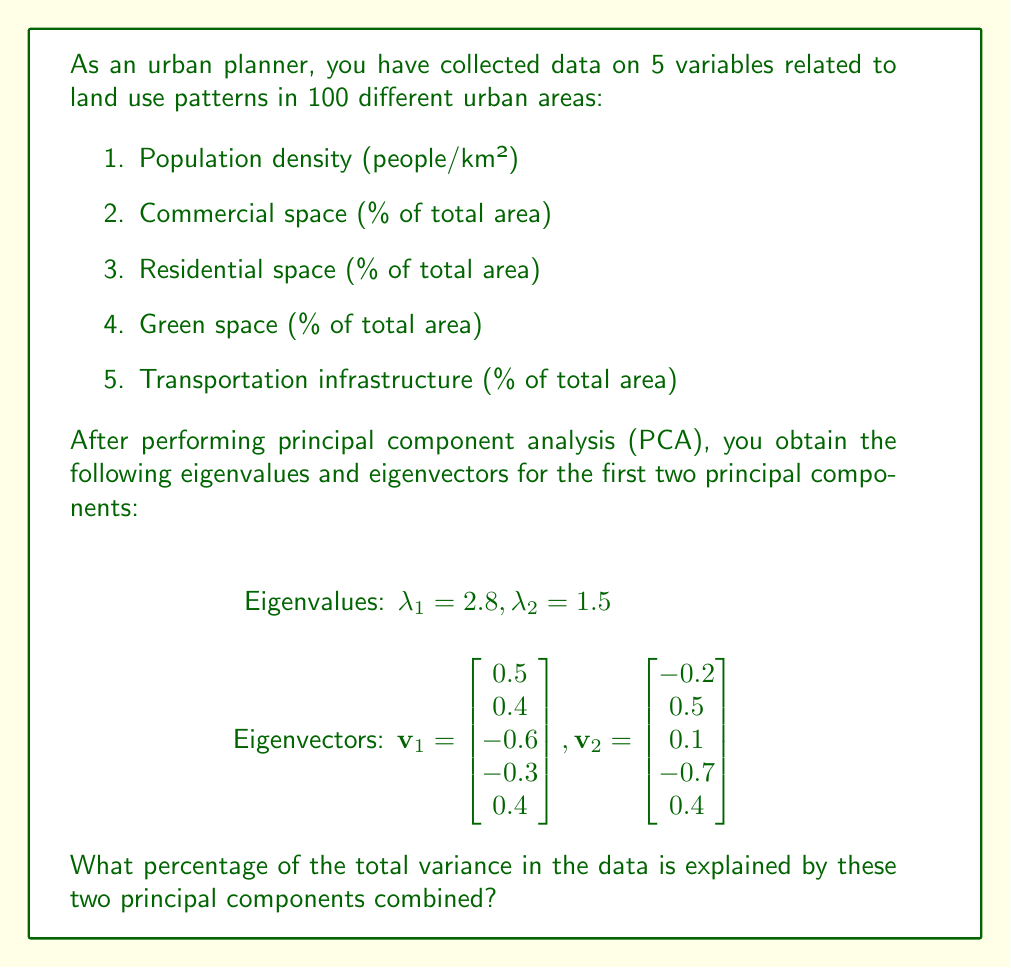Can you answer this question? To solve this problem, we need to follow these steps:

1. Calculate the total variance in the data.
2. Calculate the variance explained by each principal component.
3. Sum the variances explained by the first two principal components.
4. Calculate the percentage of total variance explained.

Step 1: Calculate the total variance
In PCA, the total variance is equal to the number of variables, which in this case is 5.

Total variance = 5

Step 2: Calculate the variance explained by each principal component
The variance explained by each principal component is equal to its corresponding eigenvalue.

Variance explained by PC1 = $\lambda_1 = 2.8$
Variance explained by PC2 = $\lambda_2 = 1.5$

Step 3: Sum the variances explained by the first two principal components
Combined variance explained = $\lambda_1 + \lambda_2 = 2.8 + 1.5 = 4.3$

Step 4: Calculate the percentage of total variance explained
Percentage of total variance explained = $\frac{\text{Combined variance explained}}{\text{Total variance}} \times 100\%$

$= \frac{4.3}{5} \times 100\% = 0.86 \times 100\% = 86\%$

Therefore, the first two principal components explain 86% of the total variance in the data.
Answer: 86% 